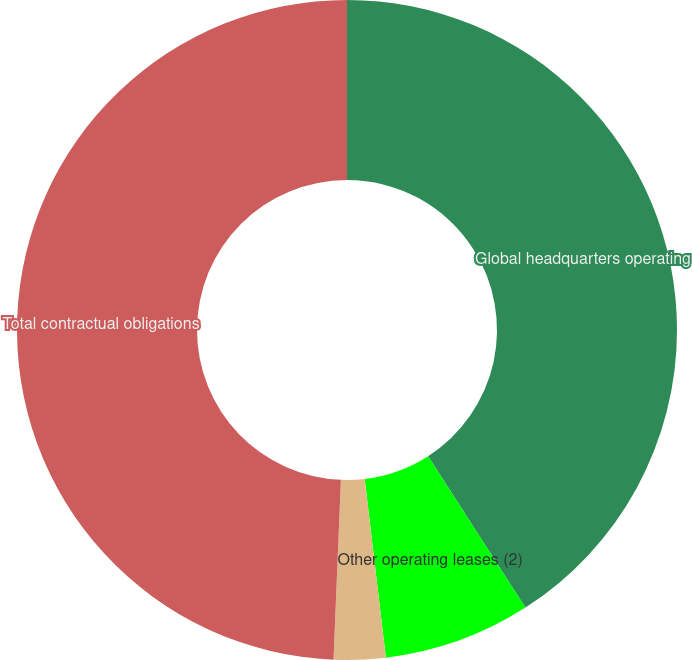Convert chart. <chart><loc_0><loc_0><loc_500><loc_500><pie_chart><fcel>Global headquarters operating<fcel>Other operating leases (2)<fcel>Other long-term obligations<fcel>Total contractual obligations<nl><fcel>40.91%<fcel>7.21%<fcel>2.53%<fcel>49.35%<nl></chart> 